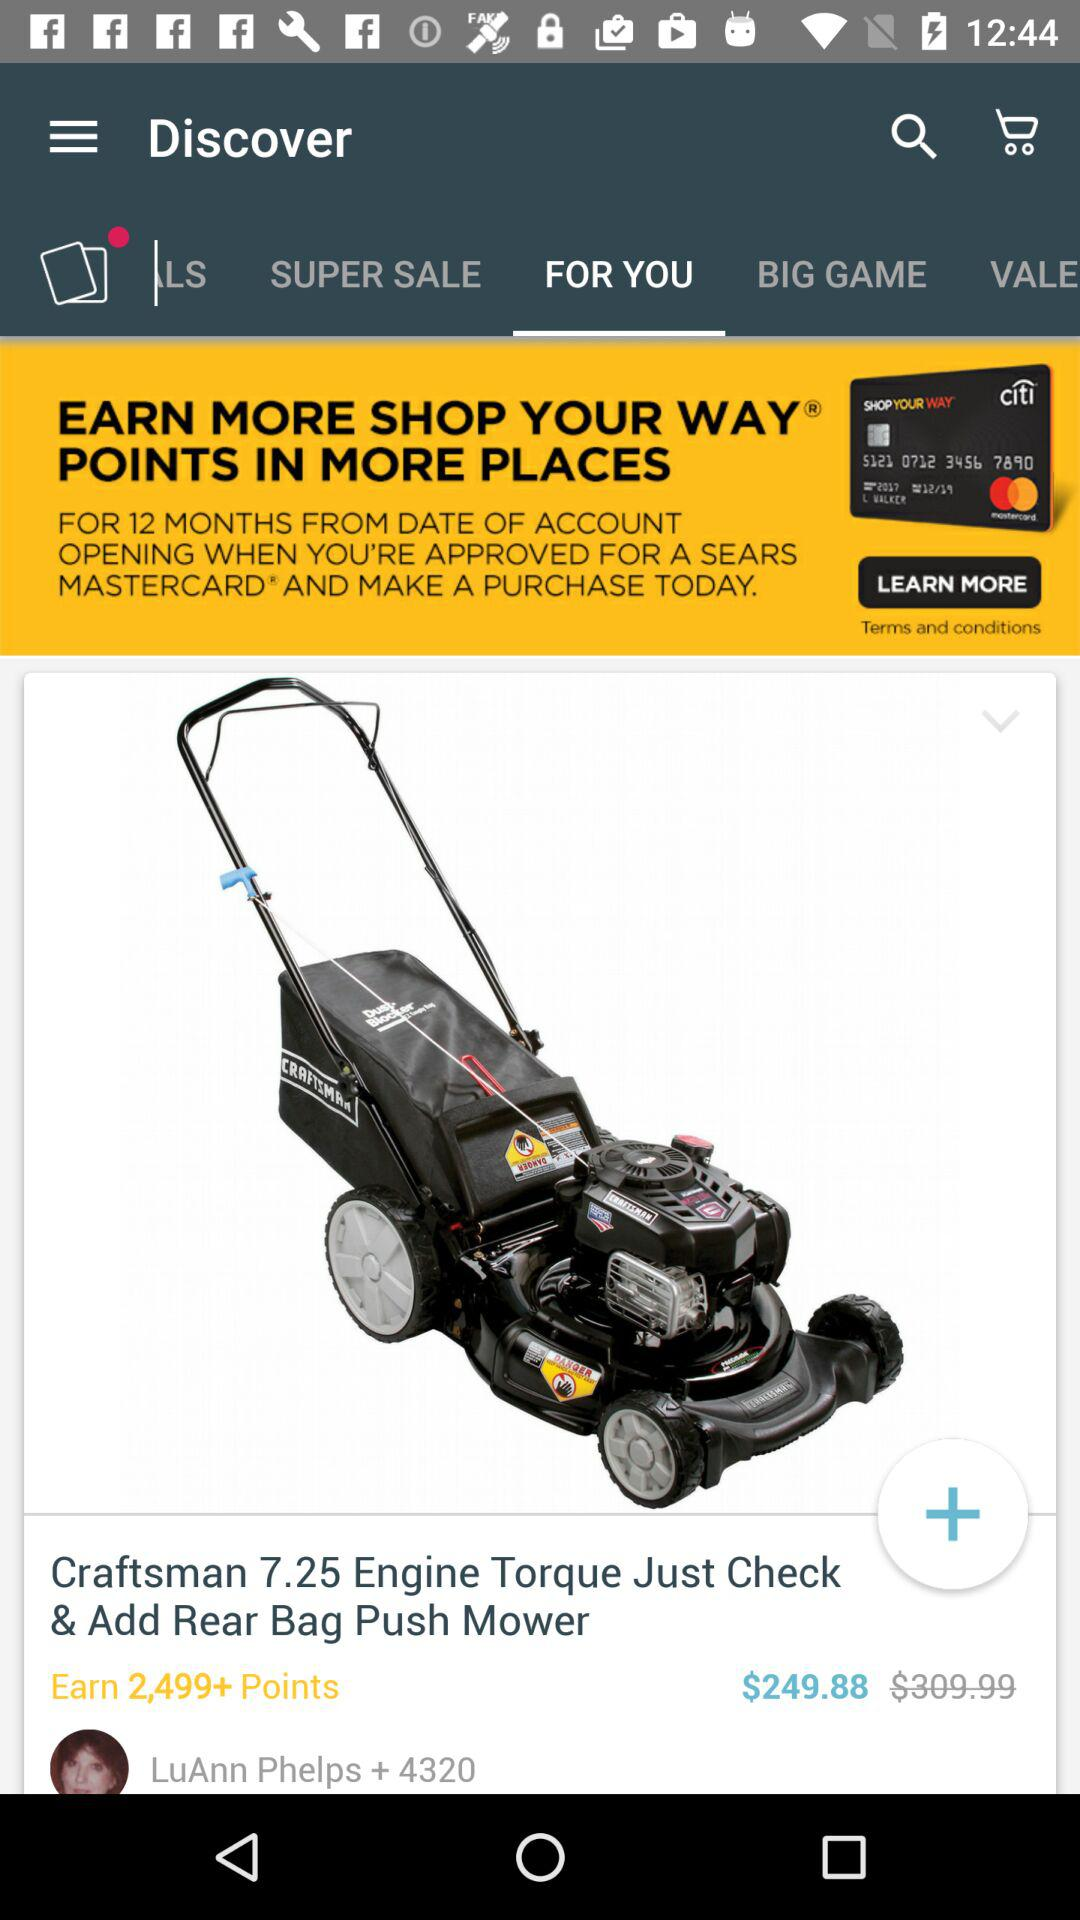How many points will I earn if I buy this lawn mower?
Answer the question using a single word or phrase. 2,499+ 